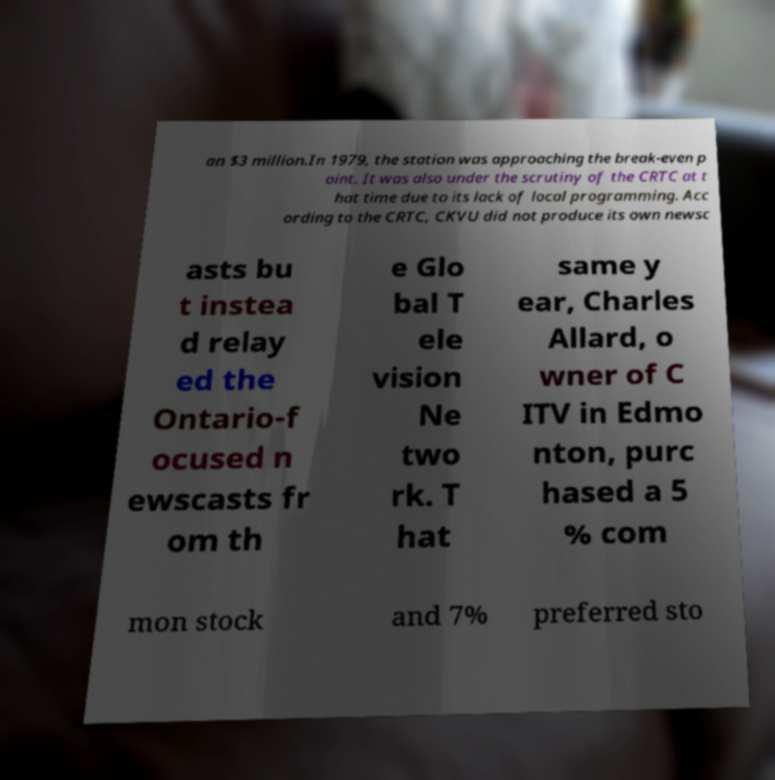There's text embedded in this image that I need extracted. Can you transcribe it verbatim? an $3 million.In 1979, the station was approaching the break-even p oint. It was also under the scrutiny of the CRTC at t hat time due to its lack of local programming. Acc ording to the CRTC, CKVU did not produce its own newsc asts bu t instea d relay ed the Ontario-f ocused n ewscasts fr om th e Glo bal T ele vision Ne two rk. T hat same y ear, Charles Allard, o wner of C ITV in Edmo nton, purc hased a 5 % com mon stock and 7% preferred sto 